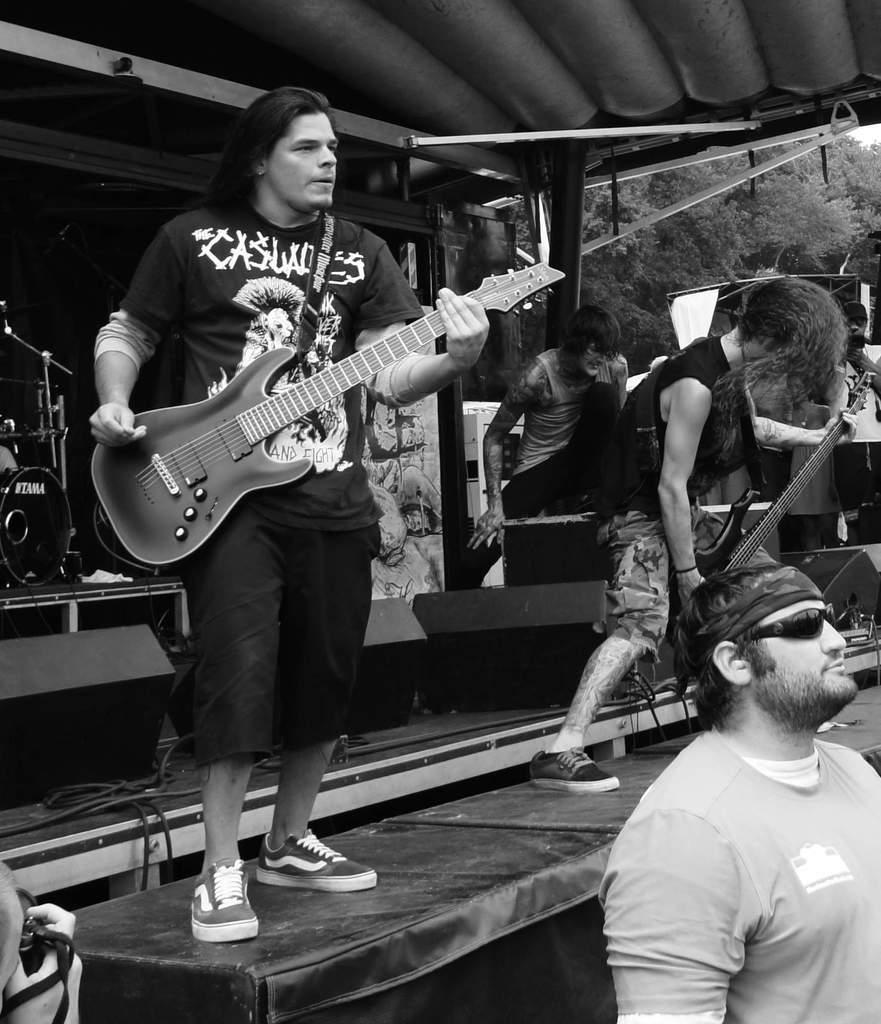Can you describe this image briefly? On the stage there are two people standing and playing guitar with black t-shirts and both are wearing shoes. Behind them there is a man. And to the right corner there are some trees. And to the left corner there are drums. To the right bottom there is man wearing goggles. 